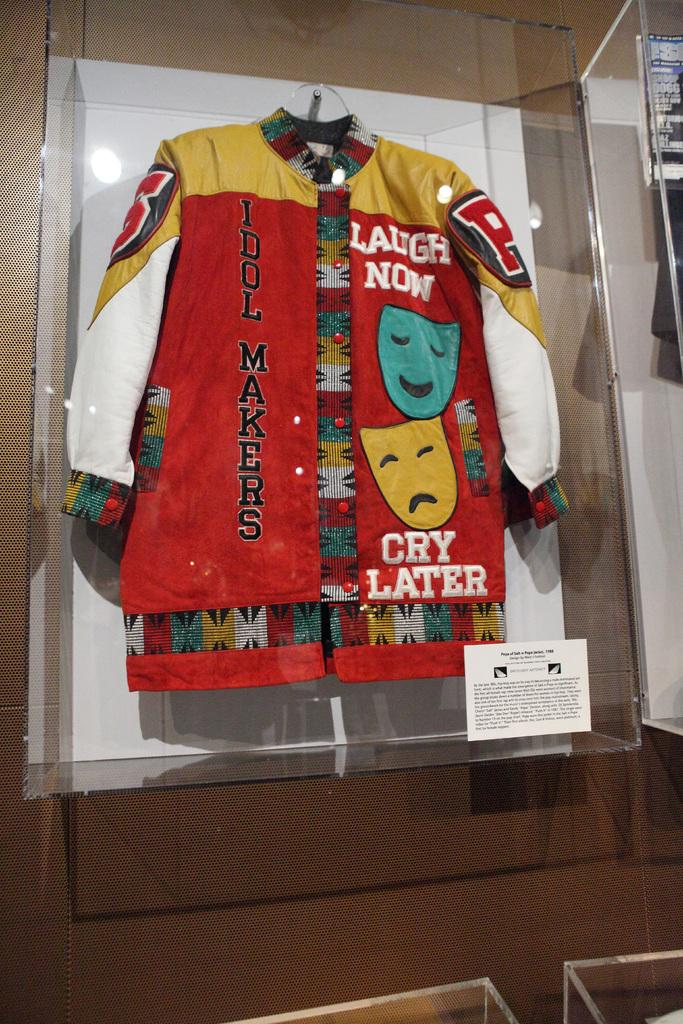<image>
Summarize the visual content of the image. The jacket shown recommends that you laugh now and cry later. 